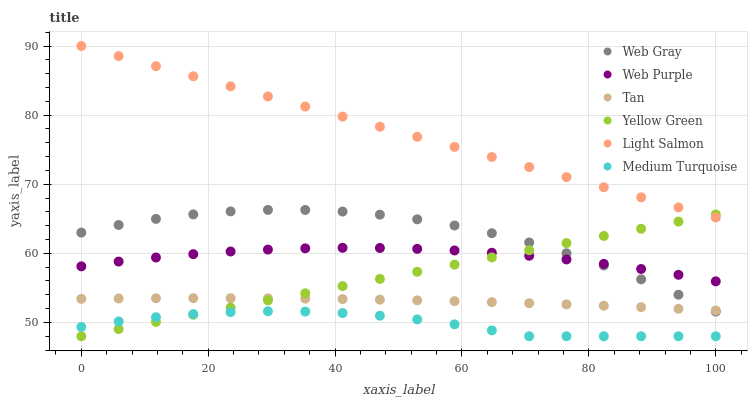Does Medium Turquoise have the minimum area under the curve?
Answer yes or no. Yes. Does Light Salmon have the maximum area under the curve?
Answer yes or no. Yes. Does Web Gray have the minimum area under the curve?
Answer yes or no. No. Does Web Gray have the maximum area under the curve?
Answer yes or no. No. Is Yellow Green the smoothest?
Answer yes or no. Yes. Is Web Gray the roughest?
Answer yes or no. Yes. Is Web Gray the smoothest?
Answer yes or no. No. Is Yellow Green the roughest?
Answer yes or no. No. Does Yellow Green have the lowest value?
Answer yes or no. Yes. Does Web Gray have the lowest value?
Answer yes or no. No. Does Light Salmon have the highest value?
Answer yes or no. Yes. Does Web Gray have the highest value?
Answer yes or no. No. Is Medium Turquoise less than Tan?
Answer yes or no. Yes. Is Tan greater than Medium Turquoise?
Answer yes or no. Yes. Does Web Purple intersect Web Gray?
Answer yes or no. Yes. Is Web Purple less than Web Gray?
Answer yes or no. No. Is Web Purple greater than Web Gray?
Answer yes or no. No. Does Medium Turquoise intersect Tan?
Answer yes or no. No. 